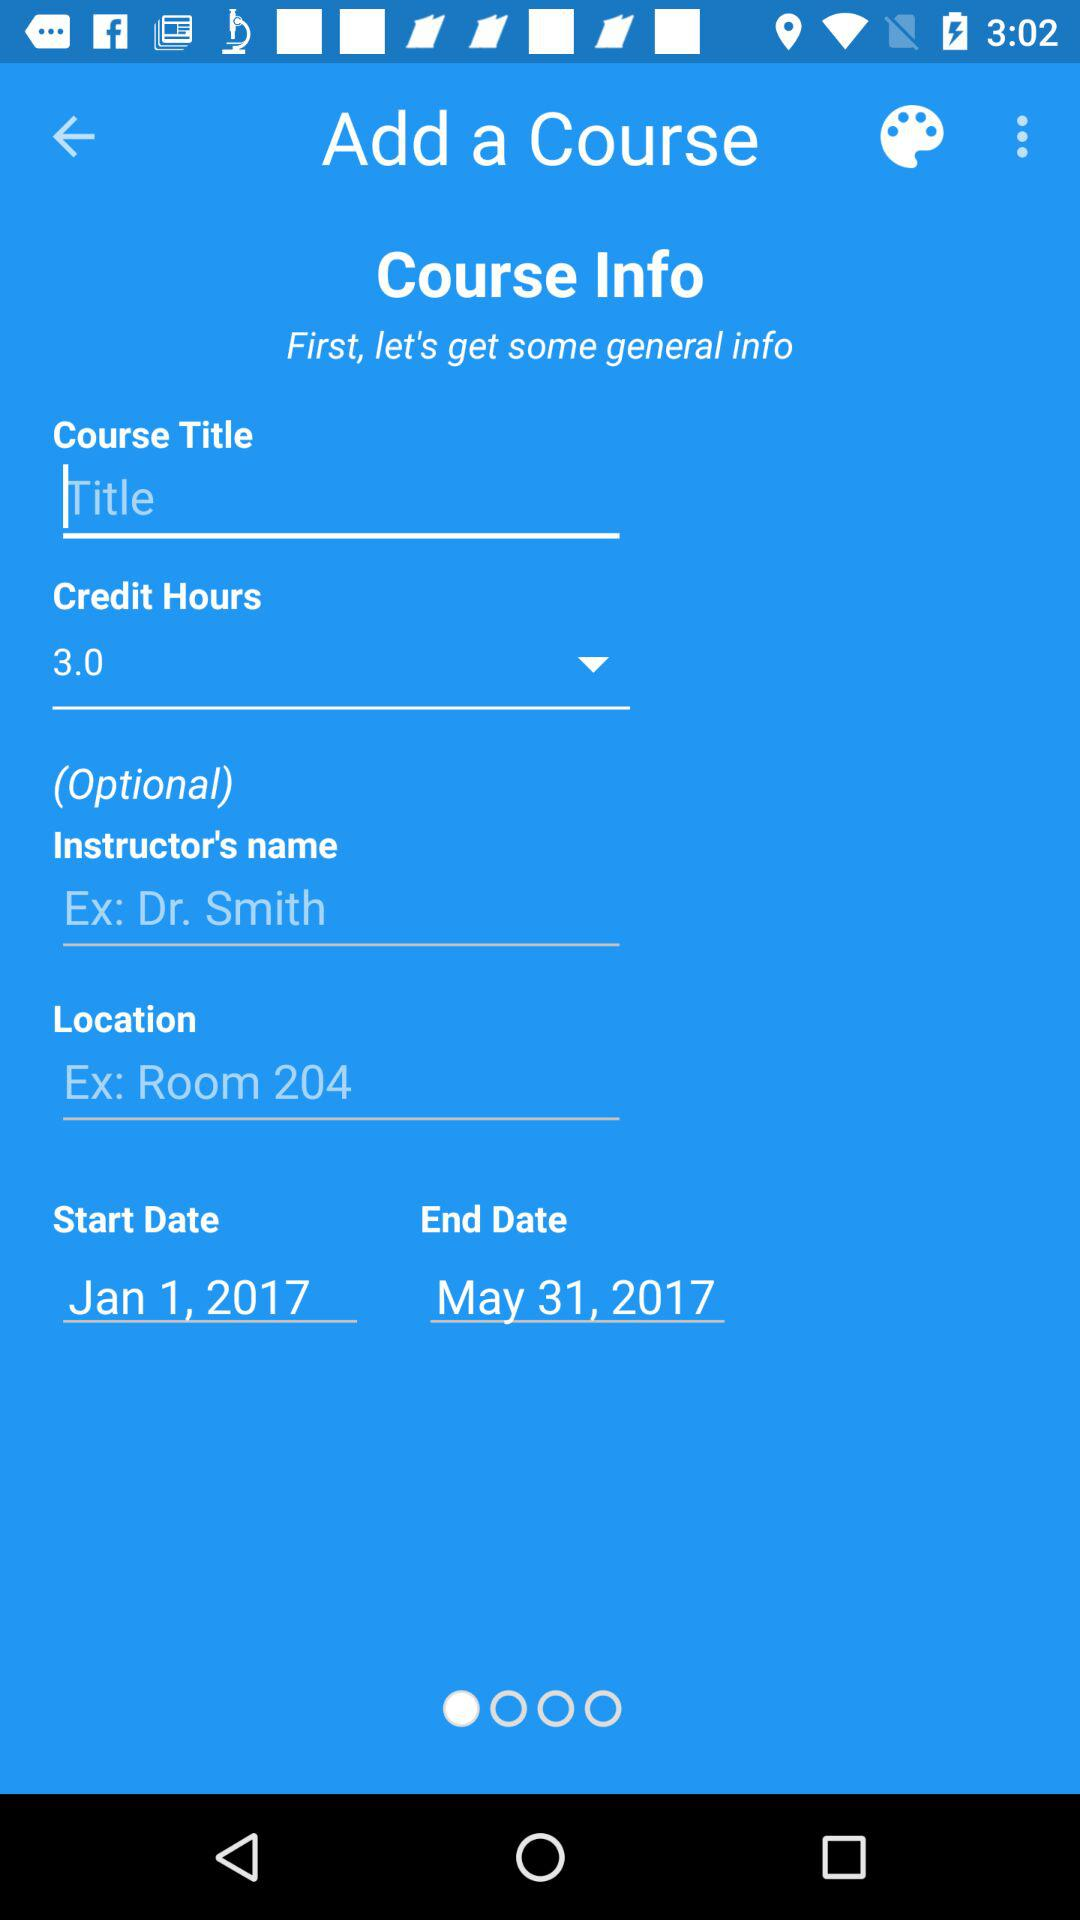What is the instructor ´ s name?
When the provided information is insufficient, respond with <no answer>. <no answer> 